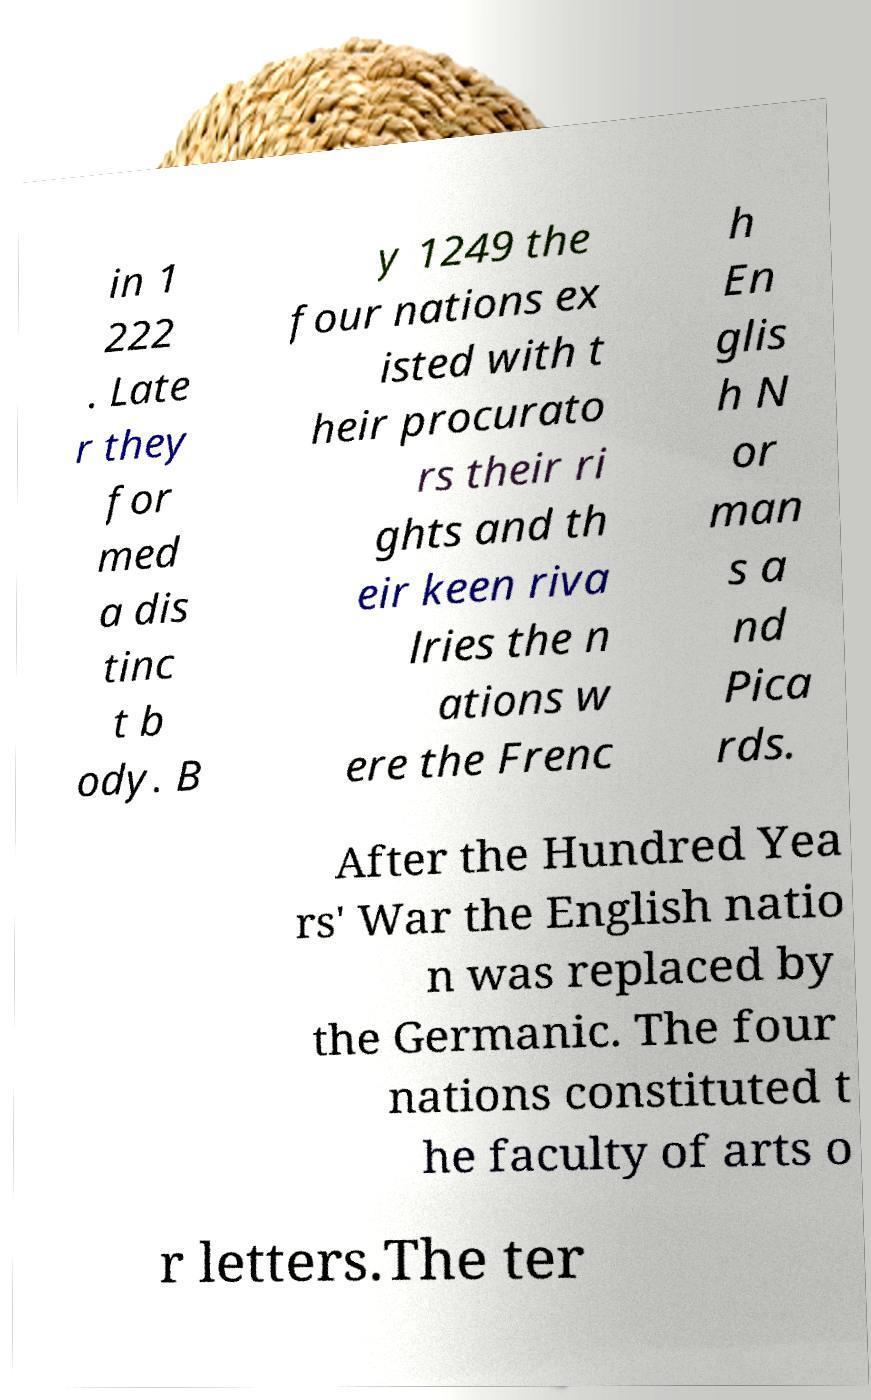For documentation purposes, I need the text within this image transcribed. Could you provide that? in 1 222 . Late r they for med a dis tinc t b ody. B y 1249 the four nations ex isted with t heir procurato rs their ri ghts and th eir keen riva lries the n ations w ere the Frenc h En glis h N or man s a nd Pica rds. After the Hundred Yea rs' War the English natio n was replaced by the Germanic. The four nations constituted t he faculty of arts o r letters.The ter 